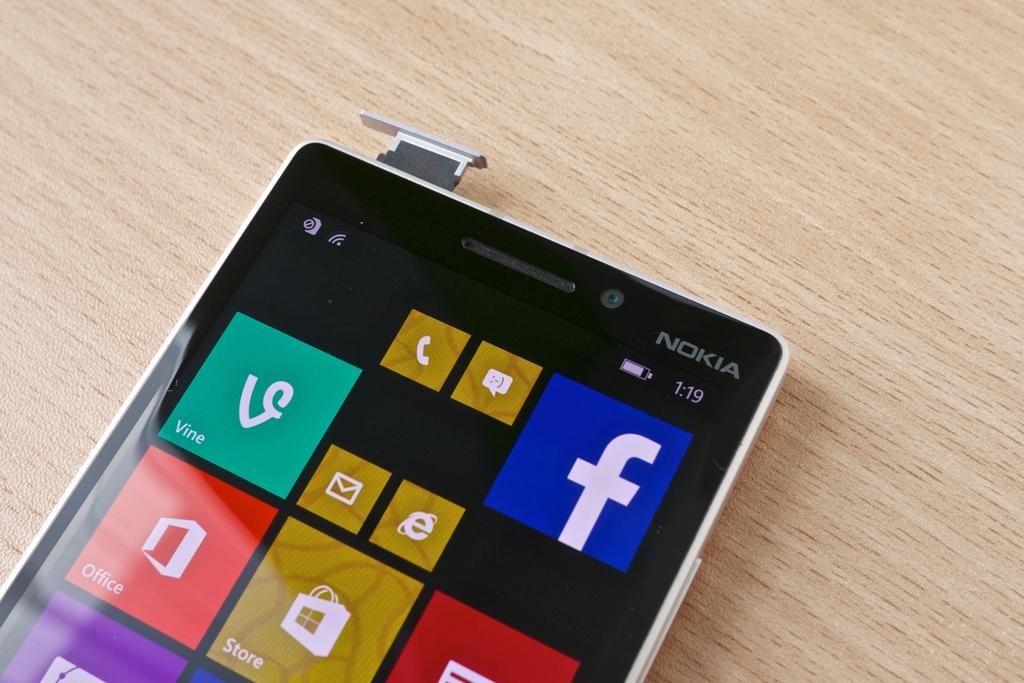<image>
Relay a brief, clear account of the picture shown. a phone that is from Nokia sits on the table 